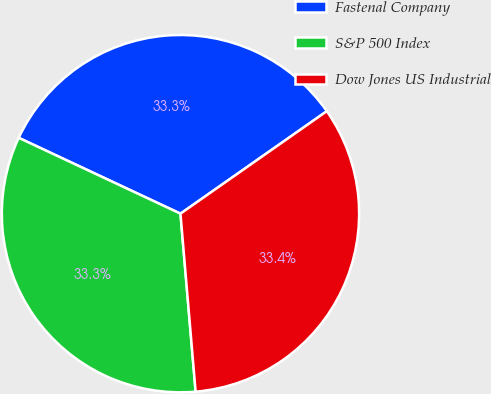Convert chart to OTSL. <chart><loc_0><loc_0><loc_500><loc_500><pie_chart><fcel>Fastenal Company<fcel>S&P 500 Index<fcel>Dow Jones US Industrial<nl><fcel>33.3%<fcel>33.33%<fcel>33.37%<nl></chart> 